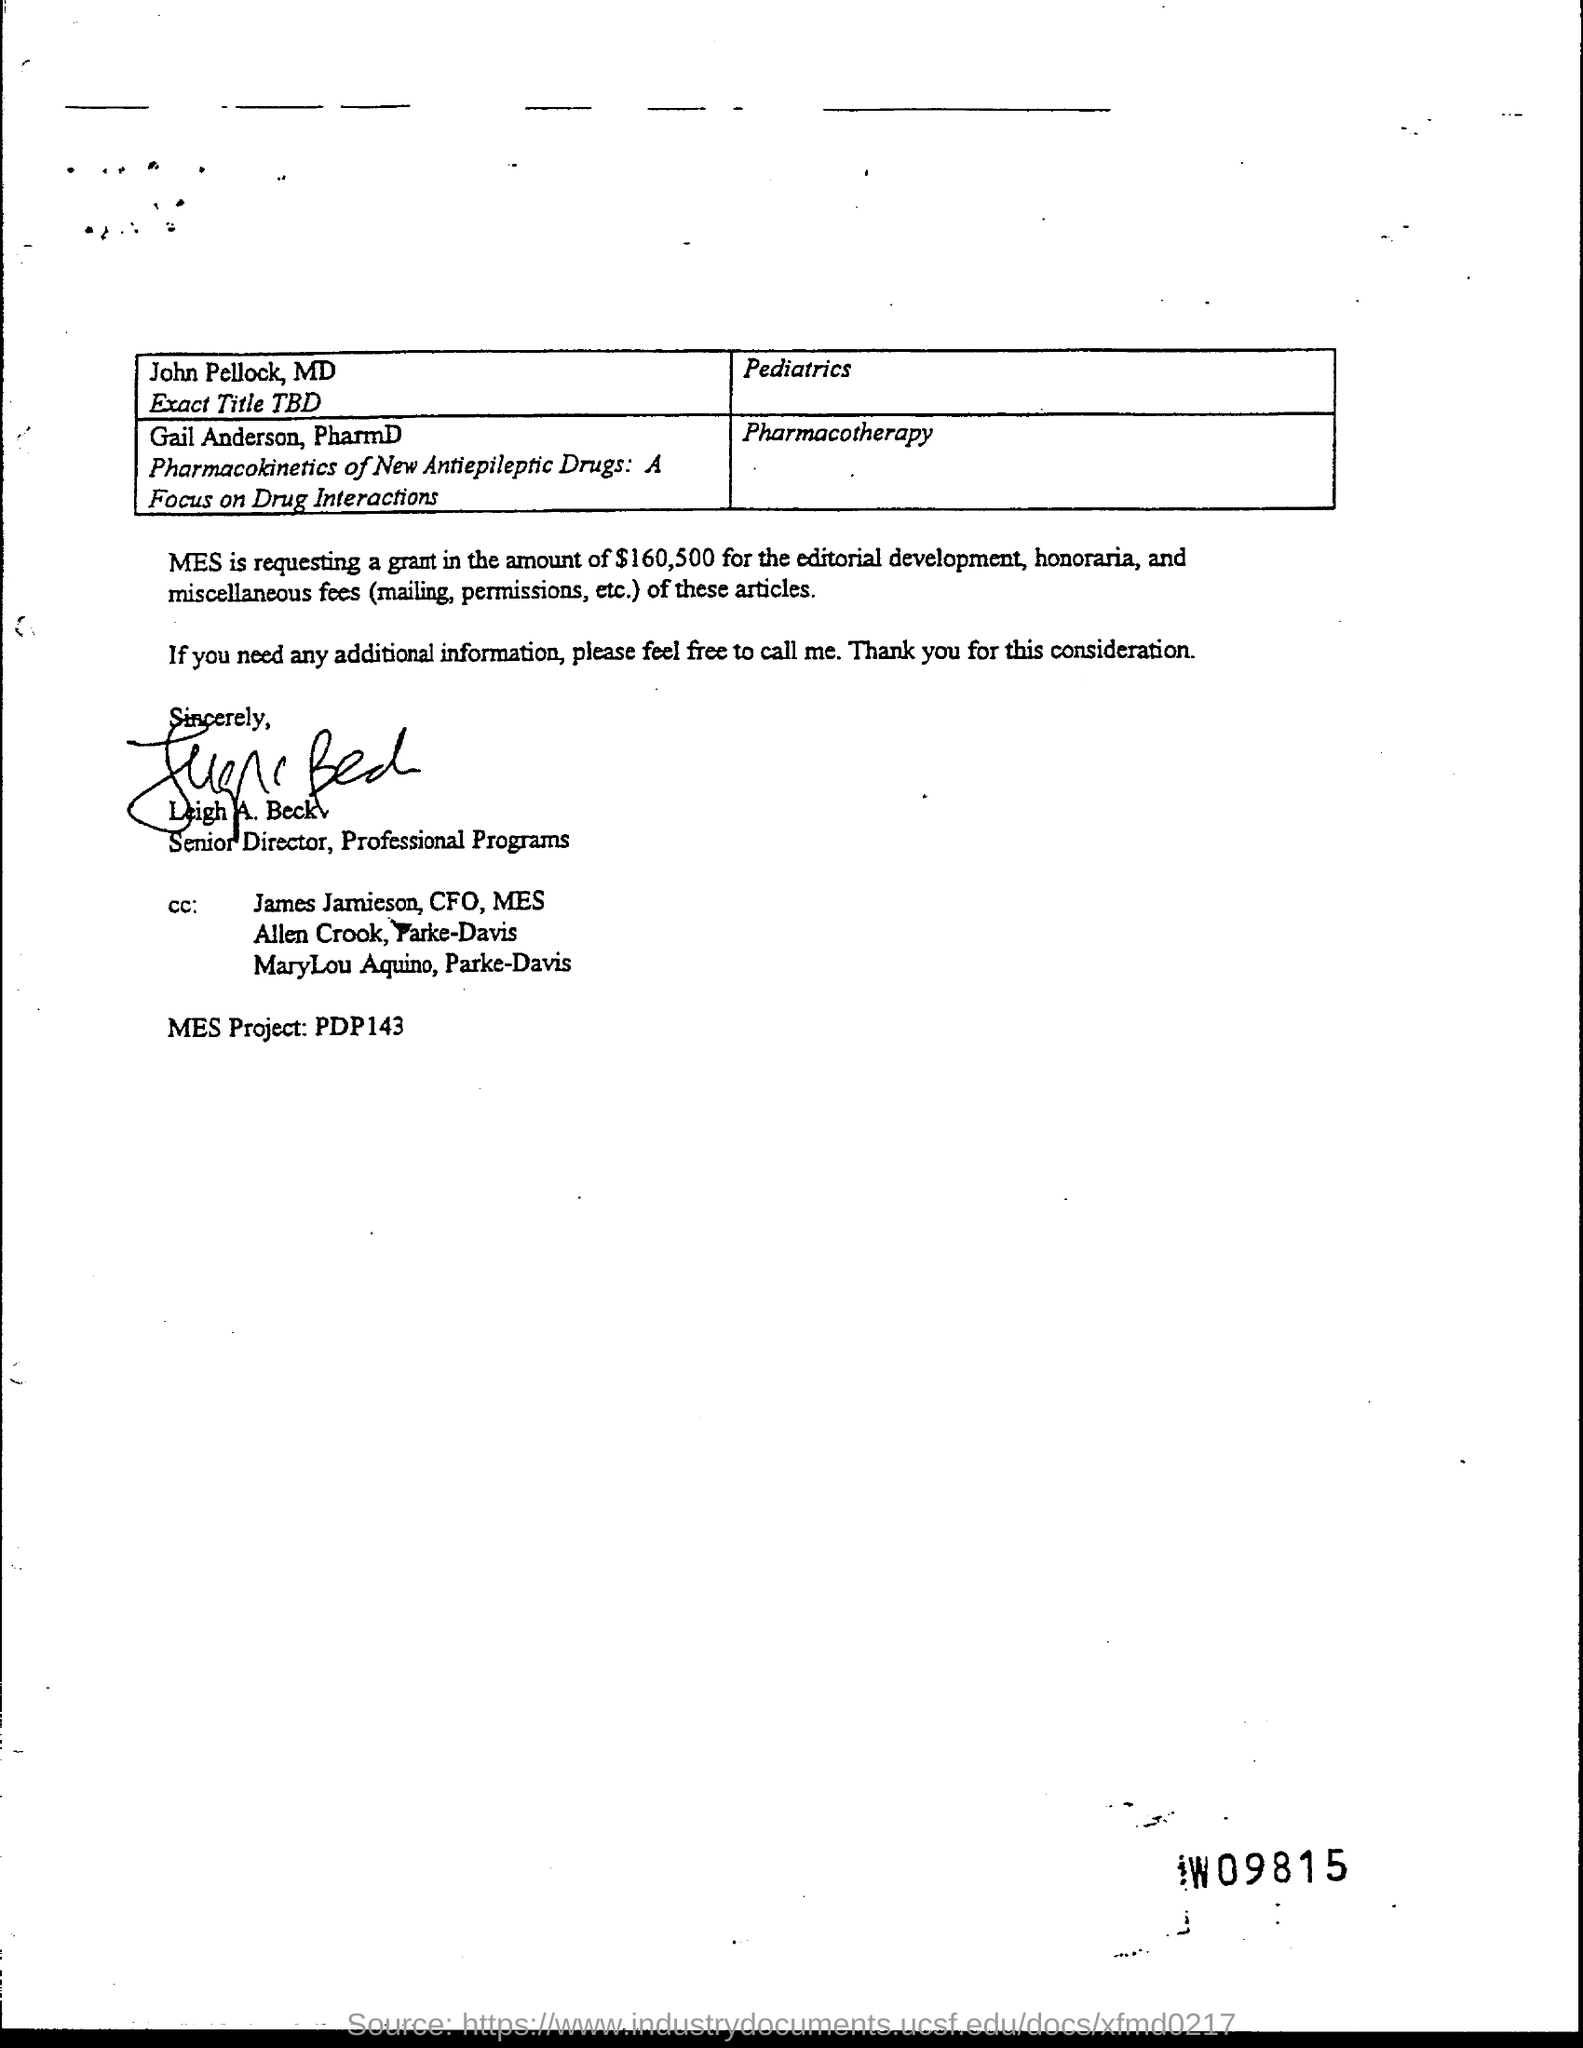What is the position of leigh a. beck?
Keep it short and to the point. Senior director. 